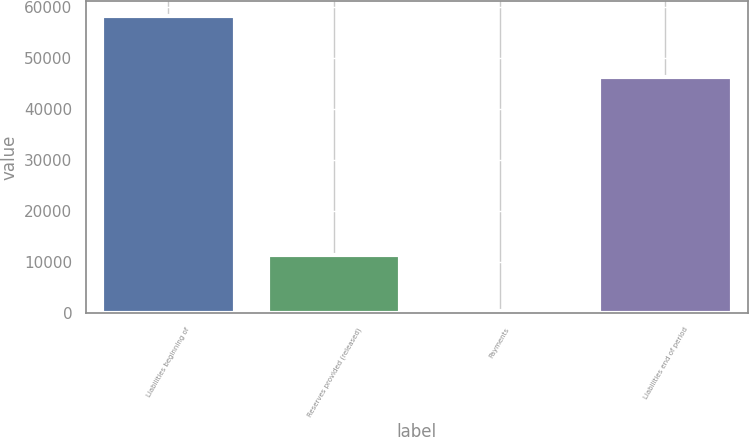Convert chart. <chart><loc_0><loc_0><loc_500><loc_500><bar_chart><fcel>Liabilities beginning of<fcel>Reserves provided (released)<fcel>Payments<fcel>Liabilities end of period<nl><fcel>58222<fcel>11433<fcel>408<fcel>46381<nl></chart> 